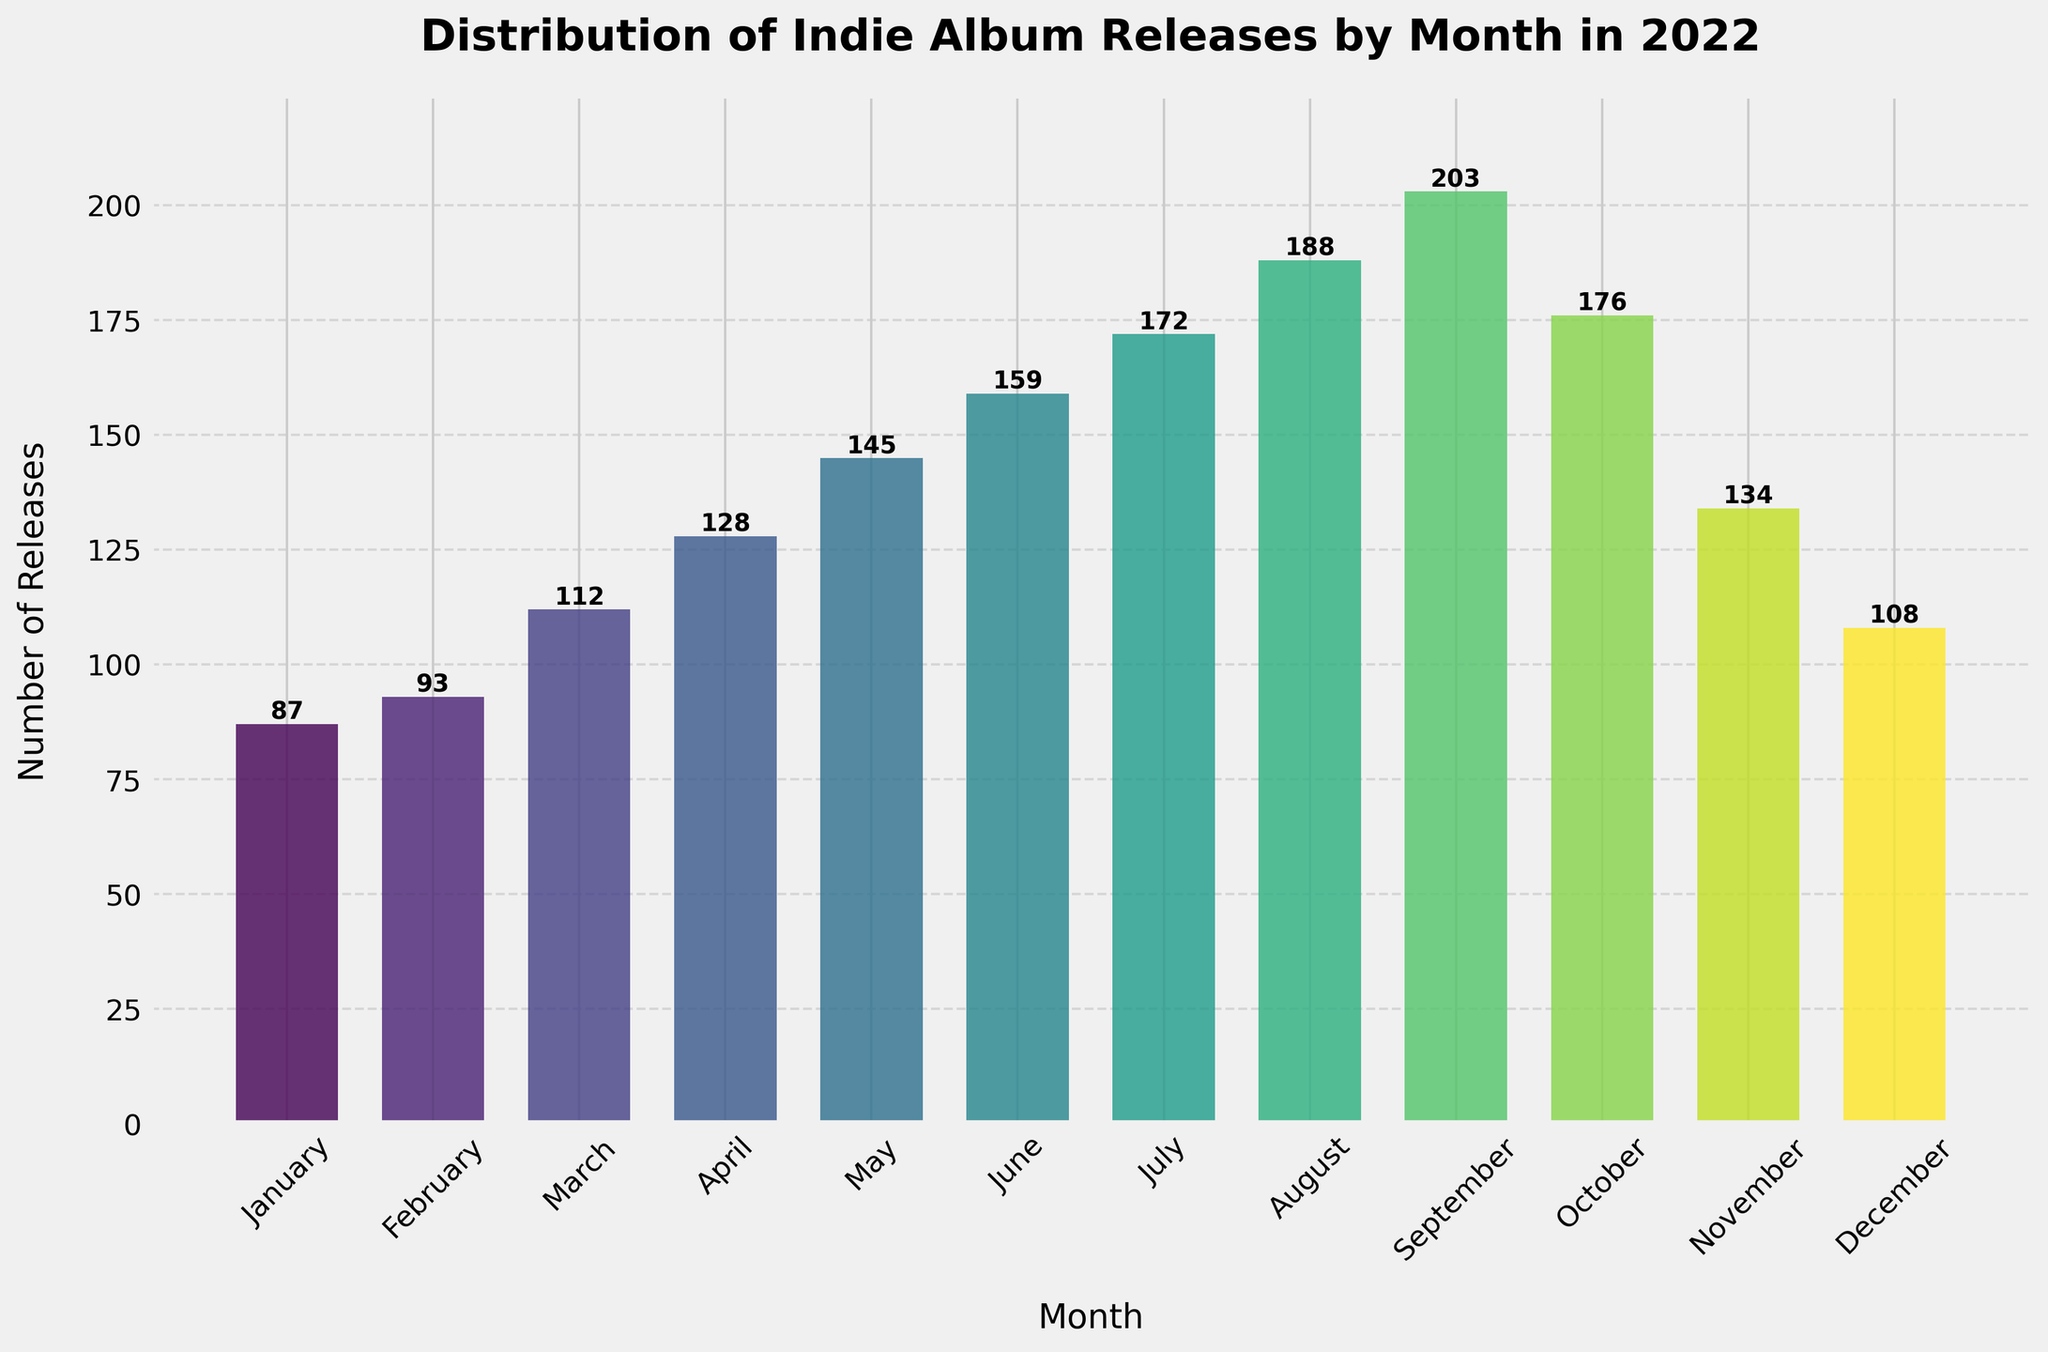What is the month with the highest number of indie album releases? Looking at the chart, September has the tallest bar, indicating it has the highest number of releases at 203.
Answer: September How many more albums were released in July compared to January? The number of releases in July is 172 and in January is 87. Subtracting January's count from July's count, 172 - 87 = 85.
Answer: 85 What is the total number of indie album releases in the first quarter of 2022? The first quarter includes January, February, and March. Add their releases: 87 (January) + 93 (February) + 112 (March) = 292.
Answer: 292 Which month had fewer releases: October or November? By comparing the heights of the bars, November (134) had fewer releases than October (176).
Answer: November What is the difference in the number of releases between April and December? April had 128 releases and December had 108. Subtracting December's count from April's, 128 - 108 = 20.
Answer: 20 How does the number of releases in June compare to the average number of releases per month for the year 2022? First, calculate the total releases for the year: 87 + 93 + 112 + 128 + 145 + 159 + 172 + 188 + 203 + 176 + 134 + 108 = 1705. The average number of releases per month is 1705 / 12 ≈ 142. June had 159 releases, which is 159 - 142 = 17 more than the average.
Answer: 17 more What is the median number of releases over all the months in 2022? To find the median: Order the numbers (87, 93, 108, 112, 128, 134, 145, 159, 172, 176, 188, 203). The middle values are 134 and 145, so the median is (134 + 145) / 2 = 139.5.
Answer: 139.5 Which month showed the largest increase in releases from the previous month? By examining the bar height differences month by month, the largest increase is from August (188) to September (203), an increase of 15 releases.
Answer: September Are there more releases in the second half of the year compared to the first half? First half (January to June): 87 + 93 + 112 + 128 + 145 + 159 = 724. Second half (July to December): 172 + 188 + 203 + 176 + 134 + 108 = 981. 981 > 724, so yes, more releases in the second half.
Answer: Yes What is the least number of releases in any single month? By looking at the shortest bar, January has the least number of releases at 87.
Answer: January 